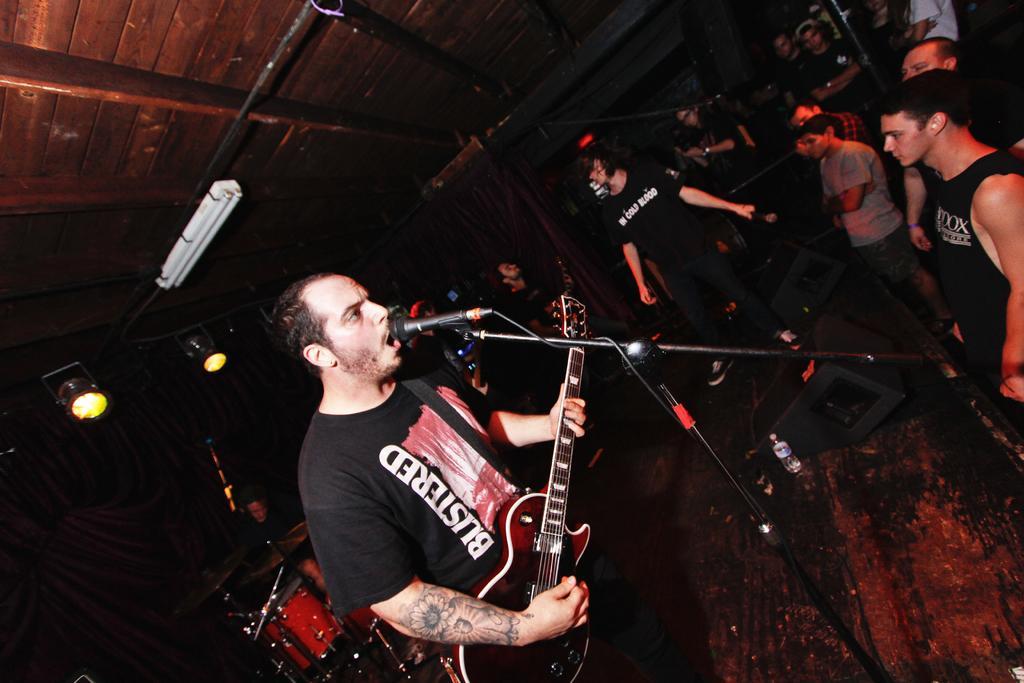How would you summarize this image in a sentence or two? In this picture there is a man singing in the microphone in front of him, there is a guitar,he is holding a guitar and people standing over here and there is a drum set in over here ceiling lights. 